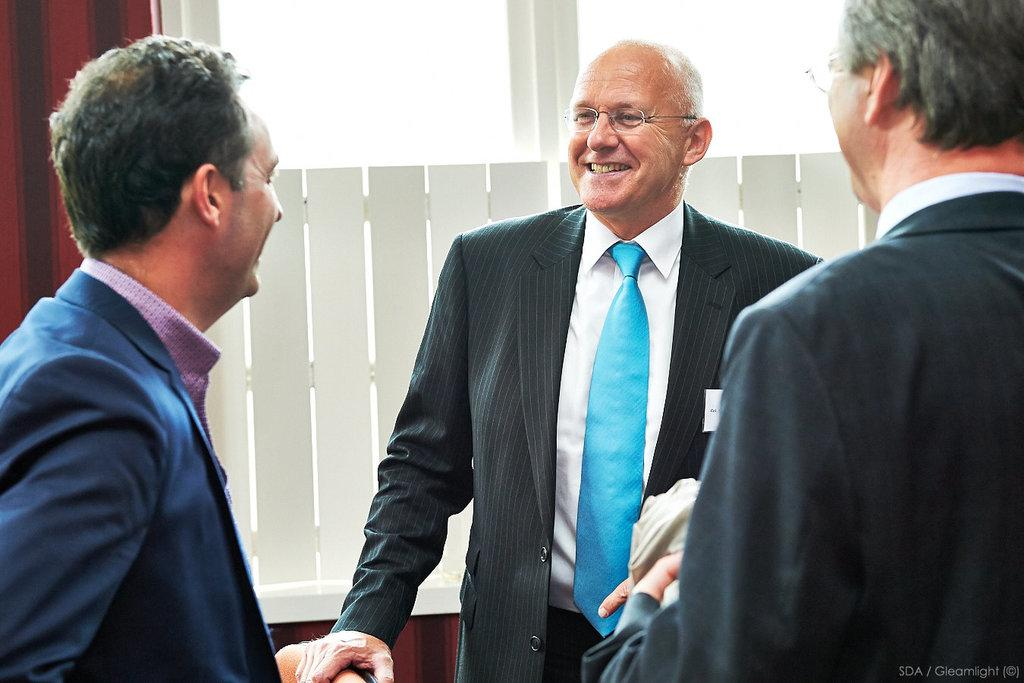What are the people in the image doing? The people in the image are standing and smiling. What can be seen in the background of the image? There is a fence and a wall in the background of the image. How does the wilderness affect the grip of the people in the image? There is no wilderness present in the image, so it cannot affect the grip of the people. 